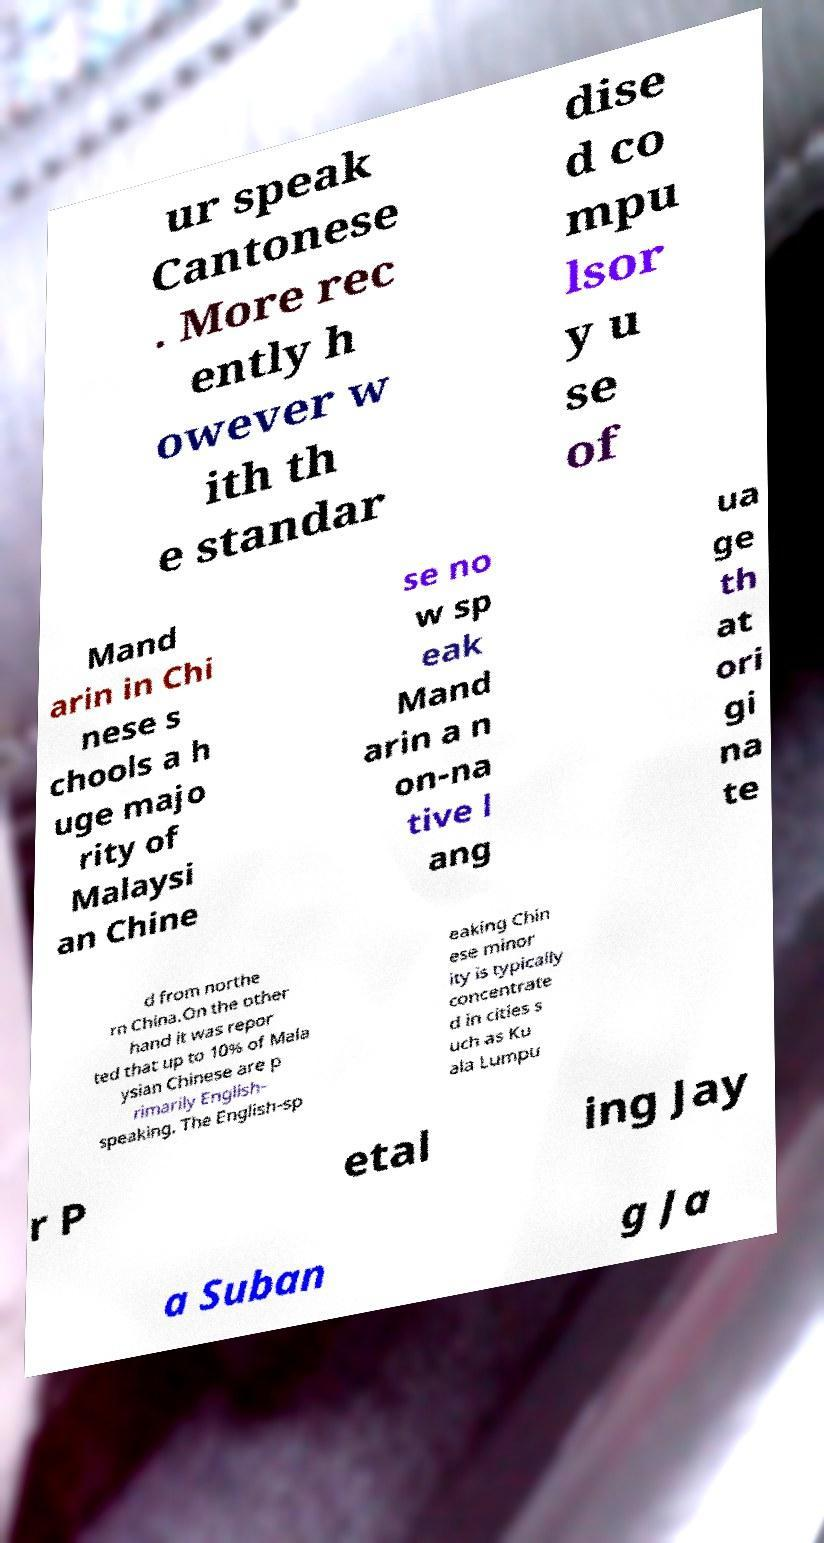Could you assist in decoding the text presented in this image and type it out clearly? ur speak Cantonese . More rec ently h owever w ith th e standar dise d co mpu lsor y u se of Mand arin in Chi nese s chools a h uge majo rity of Malaysi an Chine se no w sp eak Mand arin a n on-na tive l ang ua ge th at ori gi na te d from northe rn China.On the other hand it was repor ted that up to 10% of Mala ysian Chinese are p rimarily English- speaking. The English-sp eaking Chin ese minor ity is typically concentrate d in cities s uch as Ku ala Lumpu r P etal ing Jay a Suban g Ja 